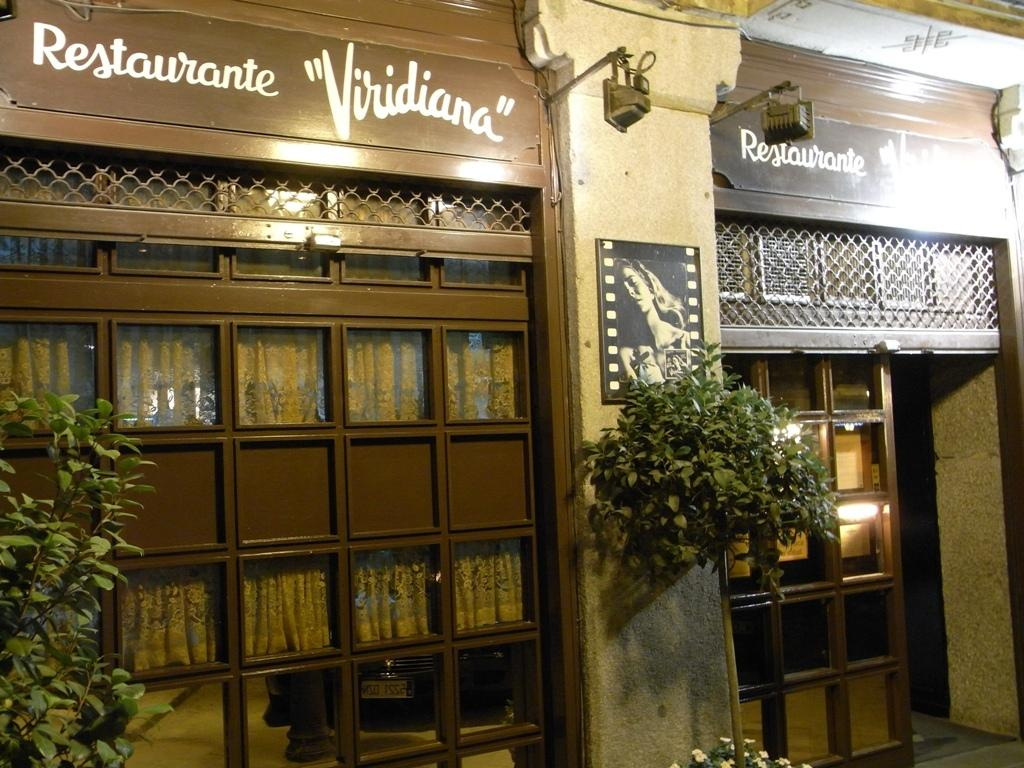<image>
Write a terse but informative summary of the picture. The entrance way to the restaurant Viridiana with plants on either side of the door. 